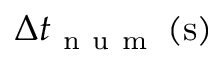<formula> <loc_0><loc_0><loc_500><loc_500>\Delta t _ { n u m } \left ( s \right )</formula> 